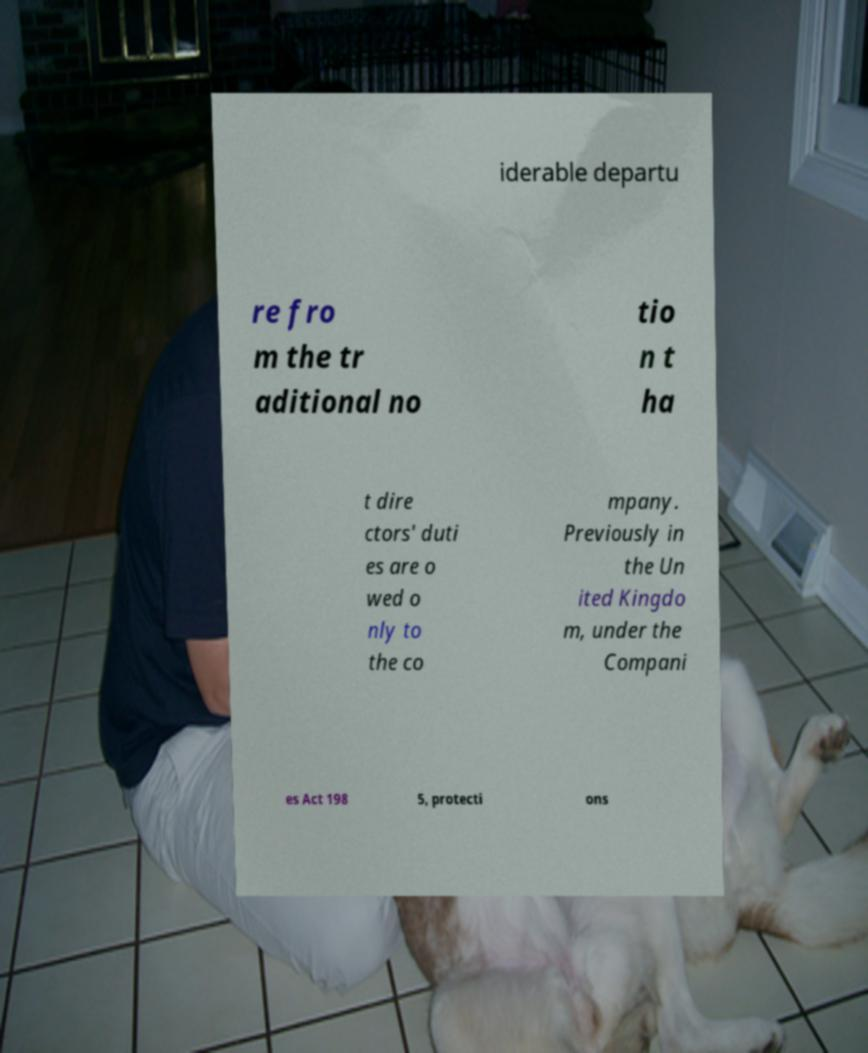Can you read and provide the text displayed in the image?This photo seems to have some interesting text. Can you extract and type it out for me? iderable departu re fro m the tr aditional no tio n t ha t dire ctors' duti es are o wed o nly to the co mpany. Previously in the Un ited Kingdo m, under the Compani es Act 198 5, protecti ons 